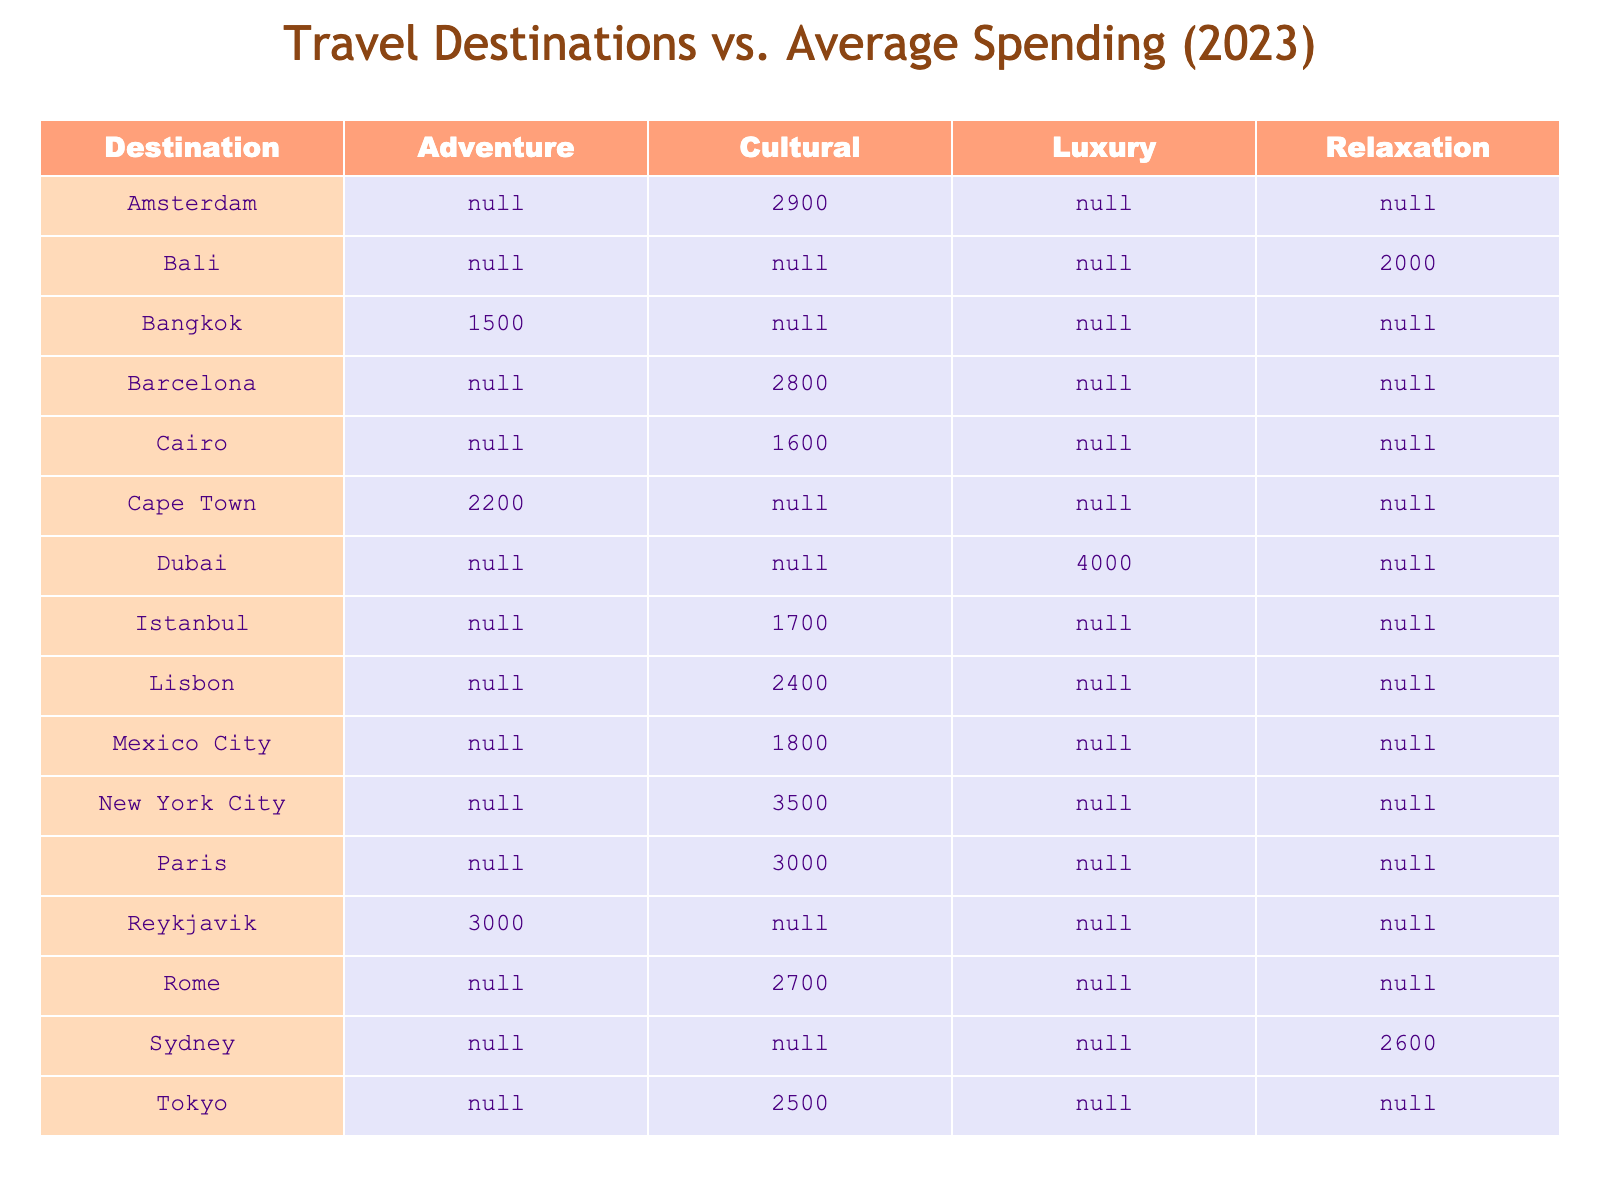What is the average spending for a trip to New York City? The average spending per trip to New York City is directly listed in the table as 3500 USD.
Answer: 3500 USD Which destination has the lowest average spending among the listed places? By reviewing the average spending amounts in the table, Bangkok has the lowest average spending at 1500 USD.
Answer: Bangkok What is the average spending for adventure category trips? The adventure category contains three destinations: Bangkok (1500), Cape Town (2200), and Reykjavik (3000). Adding these gives 1500 + 2200 + 3000 = 6700. Dividing by 3 provides the average: 6700/3 = approximately 2233.33 USD.
Answer: Approximately 2233.33 USD Is the average spending for Paris higher than for Rome? The average spending for Paris is 3000 USD, while for Rome it is 2700 USD. Since 3000 is greater than 2700, the statement is true.
Answer: Yes Which city has a higher average spending: Istanbul or Cairo? Istanbul has an average spending of 1700 USD, and Cairo has 1600 USD. Since 1700 is greater than 1600, Istanbul has a higher average spending.
Answer: Istanbul What are all the cultural destinations listed, and how much do they average spending-wise compared to luxury destinations? The cultural destinations with their average spending are: Paris (3000), New York City (3500), Barcelona (2800), Rome (2700), Mexico City (1800), Lisbon (2400), and Istanbul (1700). Summing these gives 3000 + 3500 + 2800 + 2700 + 1800 + 2400 + 1700 = 19900. The average is 19900 / 7 = approximately 2842.86 USD. The luxury destination, Dubai, has an average spending of 4000 USD, which is higher than the cultural average.
Answer: Cultural average is approximately 2842.86 USD, Luxury: 4000 USD How many destinations have an average spending above 2500 USD? Reviewing the table, the destinations with more than 2500 USD are New York City (3500), Dubai (4000), Paris (3000), and Barcelona (2800), which totals four destinations.
Answer: 4 Can you confirm if Sydney's average spending is the same as Cape Town's? Sydney has an average spending of 2600 USD and Cape Town has 2200 USD. Since 2600 does not equal 2200, the statement is false.
Answer: No What is the total average spending for trips to cultural destinations? The cultural destinations and their spending amounts are: Paris (3000), New York City (3500), Barcelona (2800), Rome (2700), Mexico City (1800), Lisbon (2400), and Istanbul (1700). Adding these gives: 3000 + 3500 + 2800 + 2700 + 1800 + 2400 + 1700 = 19900 USD.
Answer: 19900 USD 